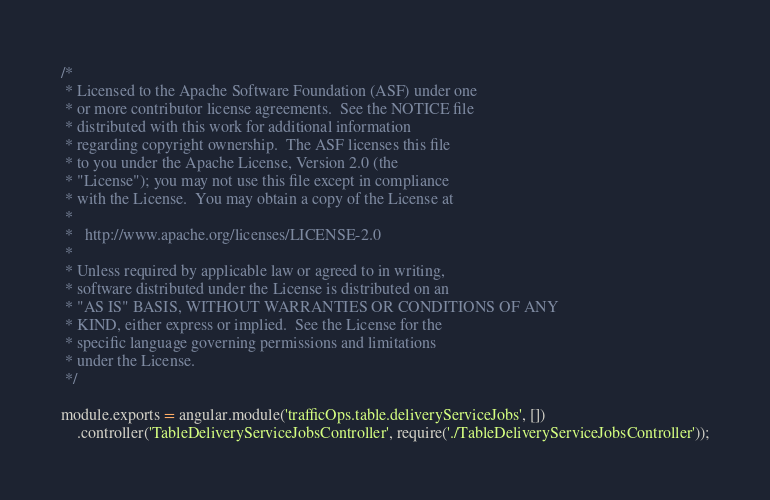<code> <loc_0><loc_0><loc_500><loc_500><_JavaScript_>/*
 * Licensed to the Apache Software Foundation (ASF) under one
 * or more contributor license agreements.  See the NOTICE file
 * distributed with this work for additional information
 * regarding copyright ownership.  The ASF licenses this file
 * to you under the Apache License, Version 2.0 (the
 * "License"); you may not use this file except in compliance
 * with the License.  You may obtain a copy of the License at
 *
 *   http://www.apache.org/licenses/LICENSE-2.0
 *
 * Unless required by applicable law or agreed to in writing,
 * software distributed under the License is distributed on an
 * "AS IS" BASIS, WITHOUT WARRANTIES OR CONDITIONS OF ANY
 * KIND, either express or implied.  See the License for the
 * specific language governing permissions and limitations
 * under the License.
 */

module.exports = angular.module('trafficOps.table.deliveryServiceJobs', [])
	.controller('TableDeliveryServiceJobsController', require('./TableDeliveryServiceJobsController'));
</code> 